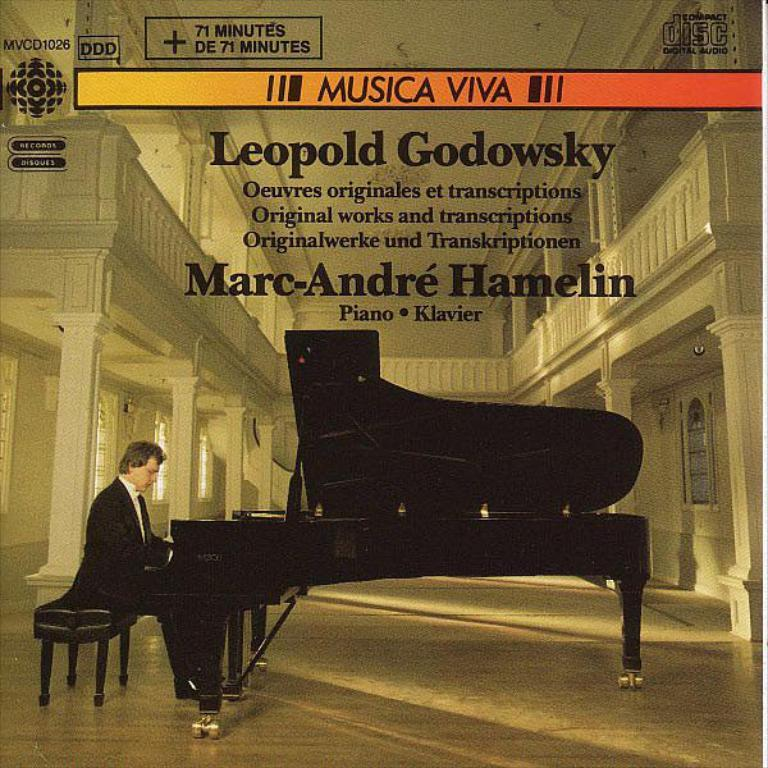What is the main subject of the image? The main subject of the image is a man. What is the man doing in the image? The man is sitting on a bench and playing a piano on the floor. What type of paper is the man using to answer the question in the image? There is no paper or question present in the image; the man is playing a piano on the floor. 